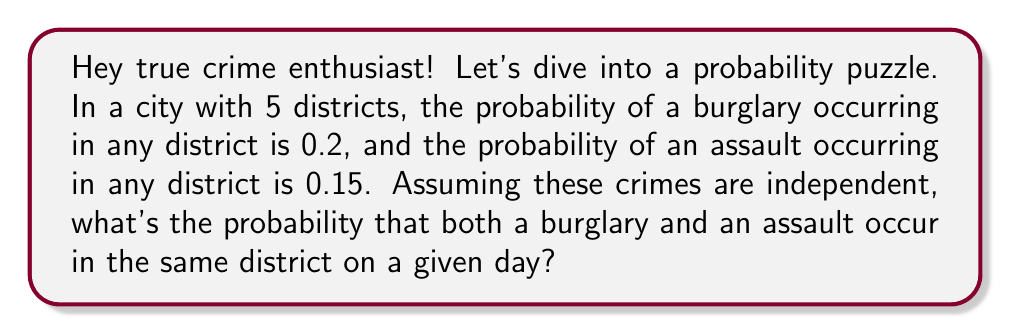What is the answer to this math problem? Let's break this down step-by-step:

1) First, we need to calculate the probability of both crimes occurring in a specific district.

   For a single district:
   $P(\text{burglary}) = 0.2$
   $P(\text{assault}) = 0.15$

   Since the events are independent:
   $P(\text{burglary and assault in one district}) = 0.2 \times 0.15 = 0.03$

2) Now, we need to consider this happening in any of the 5 districts.

3) The probability of the events occurring in the same district is the sum of the probabilities for each district:

   $P(\text{both in same district}) = 5 \times 0.03 = 0.15$

4) We can verify this using the complement method:
   
   $P(\text{not in same district}) = 1 - P(\text{both in same district})$
   
   $= 1 - 0.15 = 0.85$

Therefore, the probability of both crimes occurring in the same district is 0.15 or 15%.
Answer: 0.15 